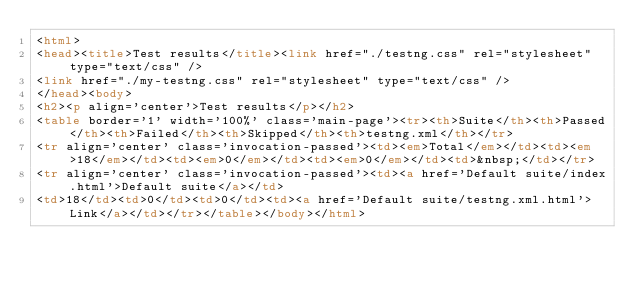<code> <loc_0><loc_0><loc_500><loc_500><_HTML_><html>
<head><title>Test results</title><link href="./testng.css" rel="stylesheet" type="text/css" />
<link href="./my-testng.css" rel="stylesheet" type="text/css" />
</head><body>
<h2><p align='center'>Test results</p></h2>
<table border='1' width='100%' class='main-page'><tr><th>Suite</th><th>Passed</th><th>Failed</th><th>Skipped</th><th>testng.xml</th></tr>
<tr align='center' class='invocation-passed'><td><em>Total</em></td><td><em>18</em></td><td><em>0</em></td><td><em>0</em></td><td>&nbsp;</td></tr>
<tr align='center' class='invocation-passed'><td><a href='Default suite/index.html'>Default suite</a></td>
<td>18</td><td>0</td><td>0</td><td><a href='Default suite/testng.xml.html'>Link</a></td></tr></table></body></html>
</code> 